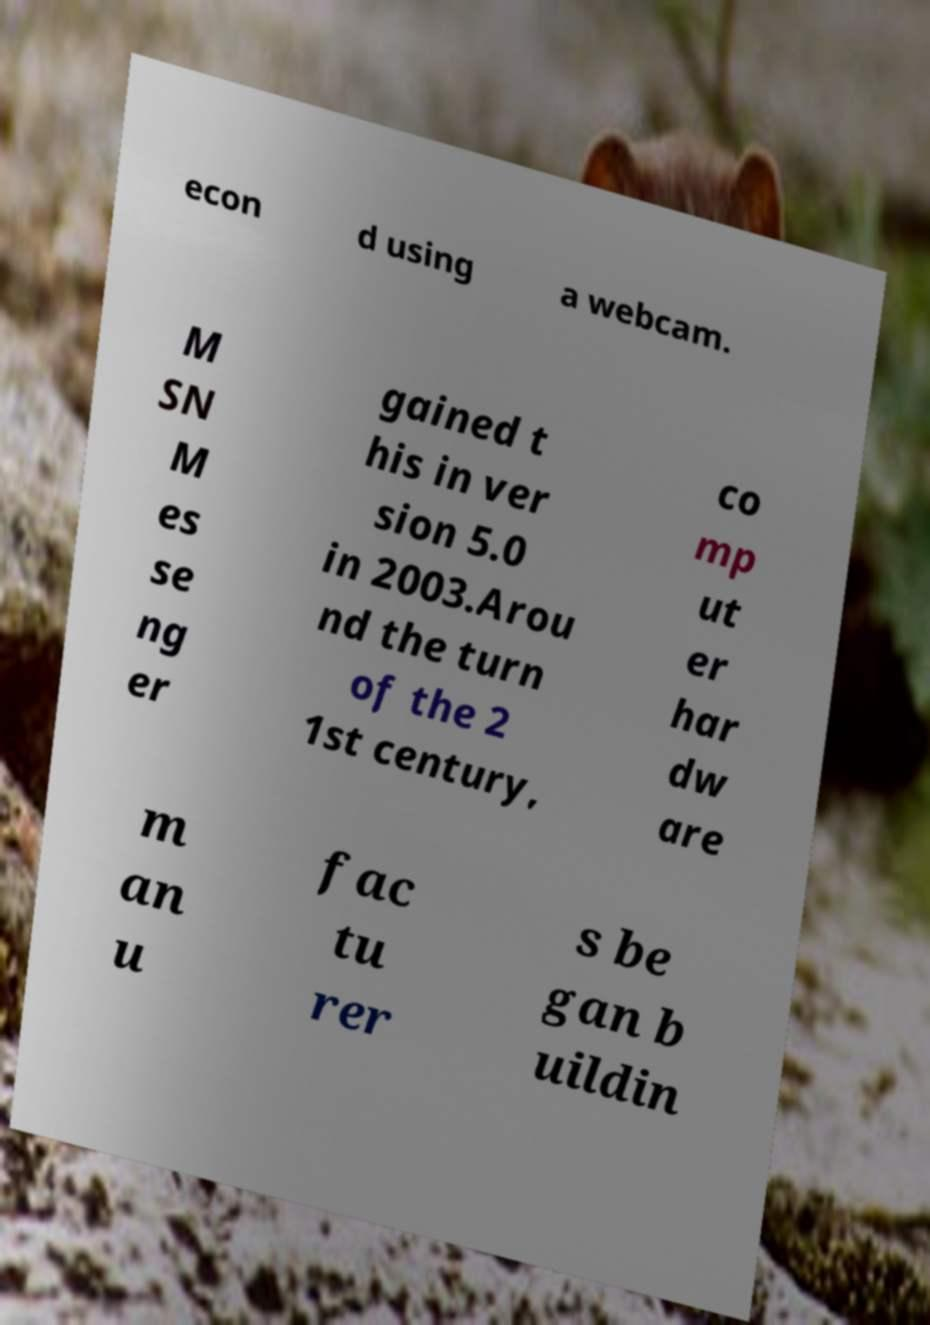What messages or text are displayed in this image? I need them in a readable, typed format. econ d using a webcam. M SN M es se ng er gained t his in ver sion 5.0 in 2003.Arou nd the turn of the 2 1st century, co mp ut er har dw are m an u fac tu rer s be gan b uildin 